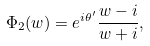<formula> <loc_0><loc_0><loc_500><loc_500>\Phi _ { 2 } ( w ) = e ^ { i \theta ^ { \prime } } \frac { w - i } { w + i } ,</formula> 